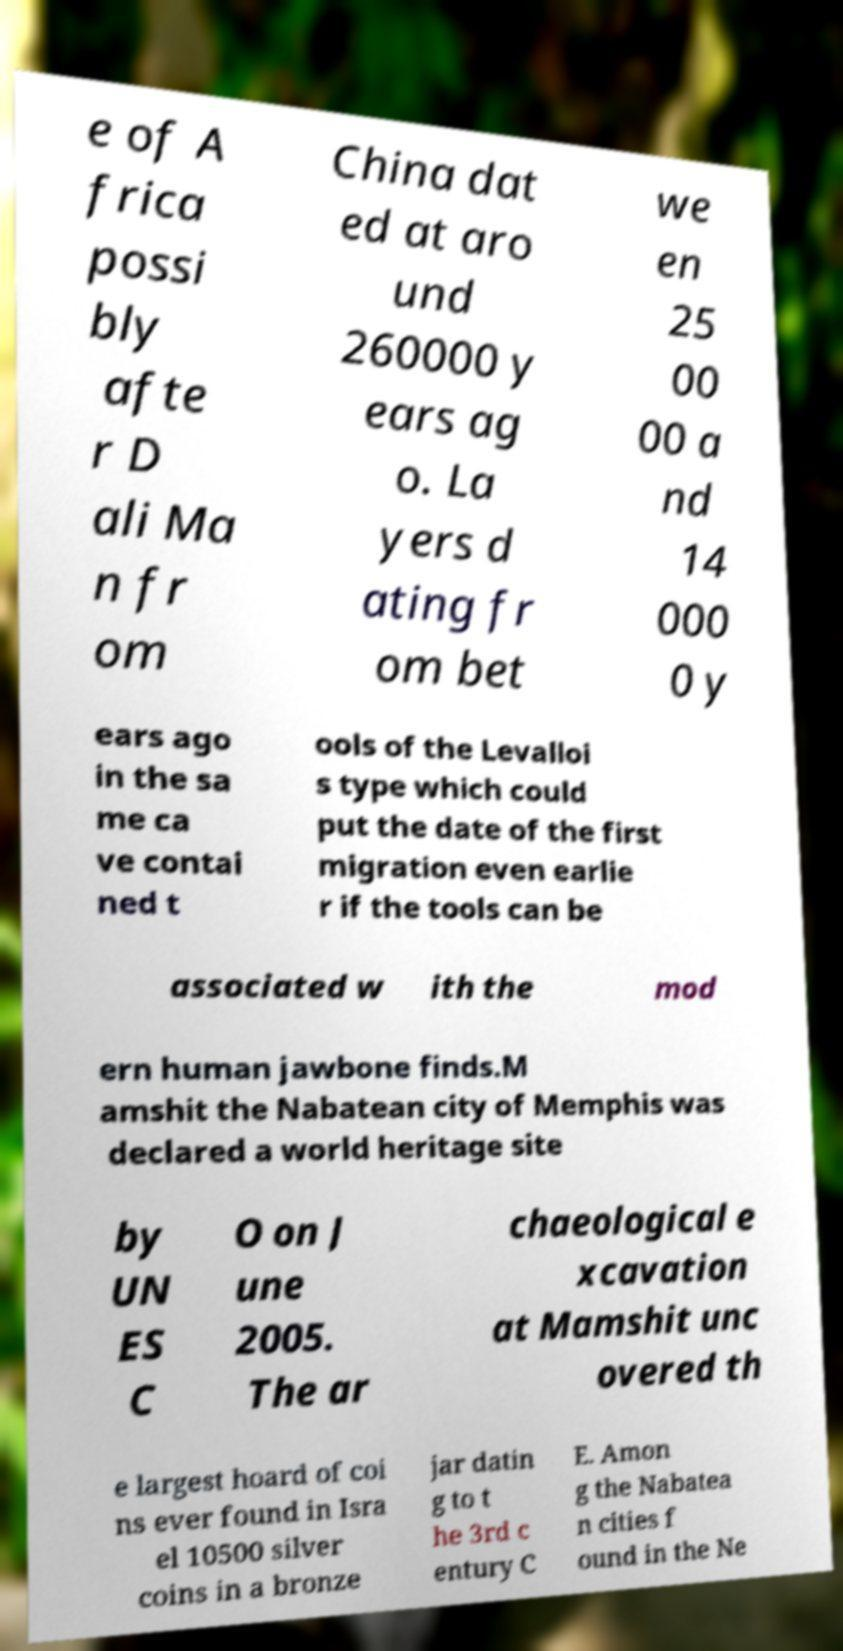Can you read and provide the text displayed in the image?This photo seems to have some interesting text. Can you extract and type it out for me? e of A frica possi bly afte r D ali Ma n fr om China dat ed at aro und 260000 y ears ag o. La yers d ating fr om bet we en 25 00 00 a nd 14 000 0 y ears ago in the sa me ca ve contai ned t ools of the Levalloi s type which could put the date of the first migration even earlie r if the tools can be associated w ith the mod ern human jawbone finds.M amshit the Nabatean city of Memphis was declared a world heritage site by UN ES C O on J une 2005. The ar chaeological e xcavation at Mamshit unc overed th e largest hoard of coi ns ever found in Isra el 10500 silver coins in a bronze jar datin g to t he 3rd c entury C E. Amon g the Nabatea n cities f ound in the Ne 